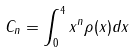<formula> <loc_0><loc_0><loc_500><loc_500>C _ { n } = \int _ { 0 } ^ { 4 } x ^ { n } \rho ( x ) d x</formula> 